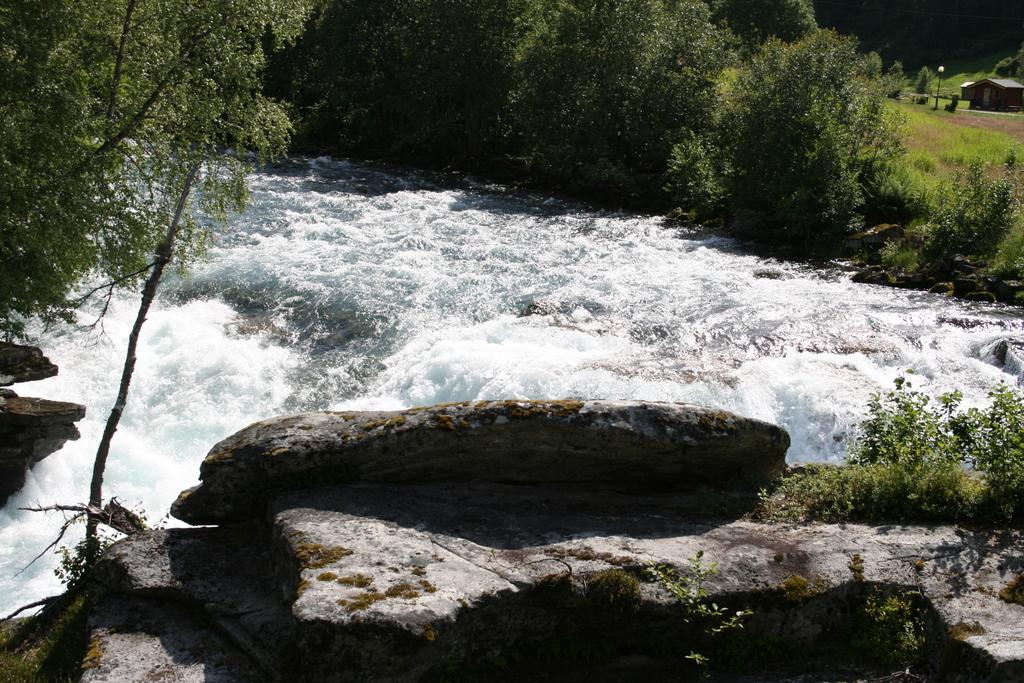What is the main feature of the image? The main feature of the image is flowing water. What else can be seen in the image besides the flowing water? Rocks, trees, plants, a pole, and a house are visible in the image. Can you describe the natural elements in the image? Trees and plants are present in the image, along with the flowing water. What type of structure is in the image? There is a house in the image. What is the tendency of the turkey in the image? There is no turkey present in the image. What type of stone is used to build the house in the image? The provided facts do not mention the type of stone used to build the house, if any. 